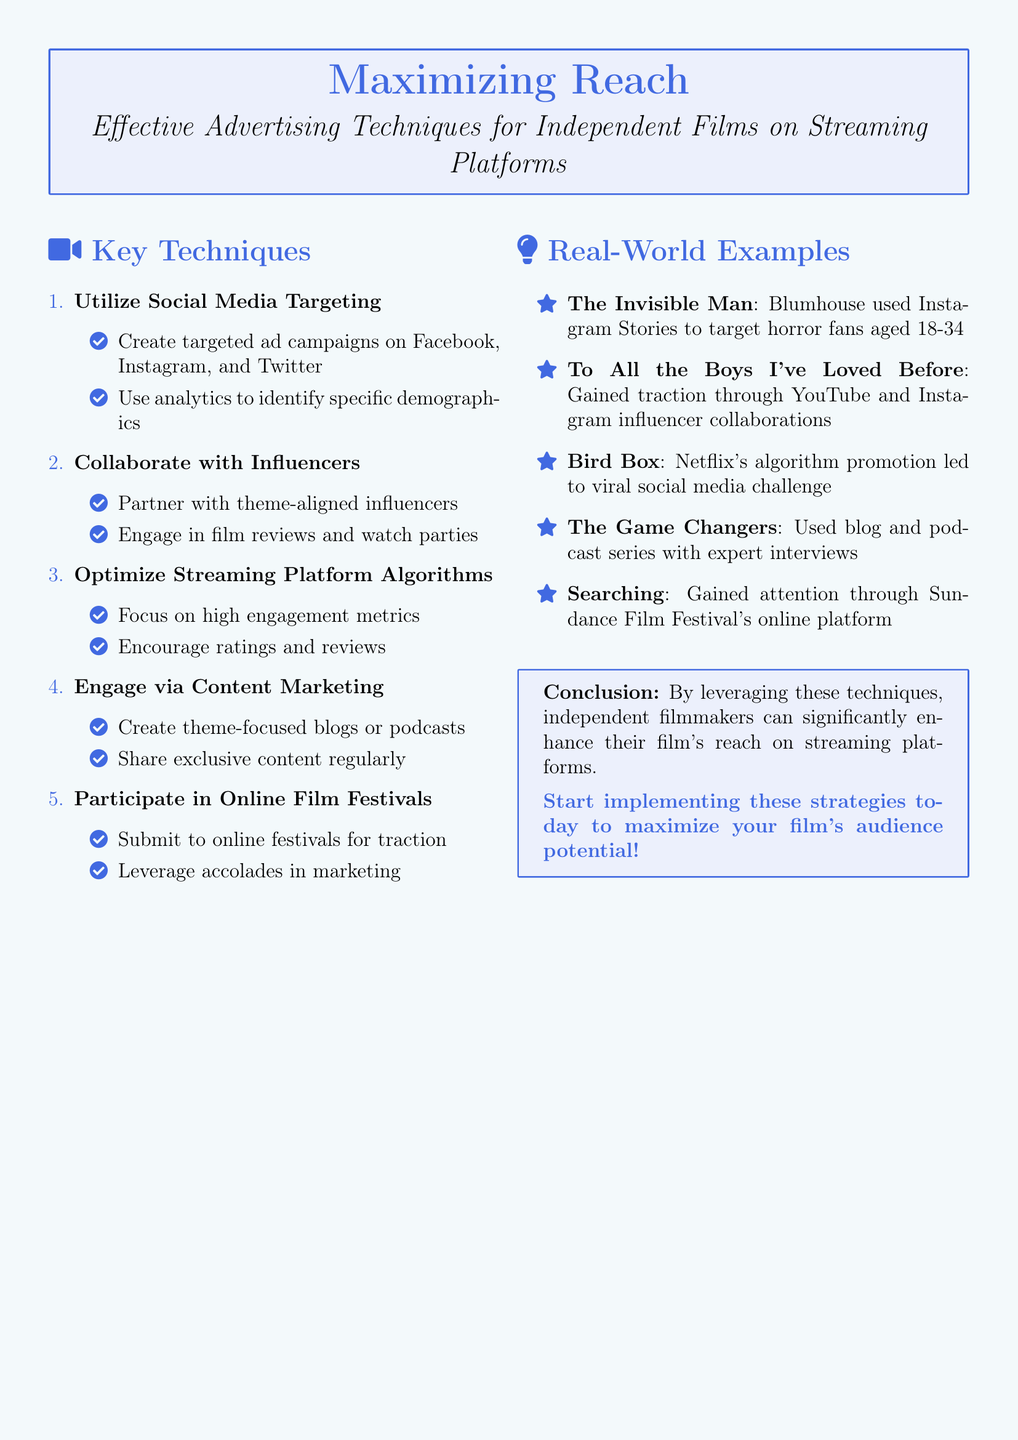What is the title of the document? The title is presented prominently in the header of the document.
Answer: Maximizing Reach: Effective Advertising Techniques for Independent Films on Streaming Platforms Which social media platforms are mentioned for targeted ad campaigns? The social media platforms listed in the document are found in the advertising techniques section.
Answer: Facebook, Instagram, and Twitter How many key techniques are presented in the document? The number of key techniques can be found in the enumeration section of the document.
Answer: Five What is one real-world example of a film mentioned in the document? The document provides several film examples in the real-world examples section.
Answer: The Invisible Man What is recommended to encourage engagement on streaming platforms? The recommendation can be derived from the strategies section discussing engagement metrics.
Answer: Ratings and reviews Which festival is suggested for independent filmmakers to participate in online? The type of festival referenced for online participation is specified under the techniques.
Answer: Online film festivals What type of marketing is advised for effective audience reach? The type of marketing discussed for engagement is found in the advertising techniques section.
Answer: Content marketing What is the conclusion about implementing the strategies? The conclusion summarizing the document's main focus is found in the final box.
Answer: Enhance their film's reach on streaming platforms 